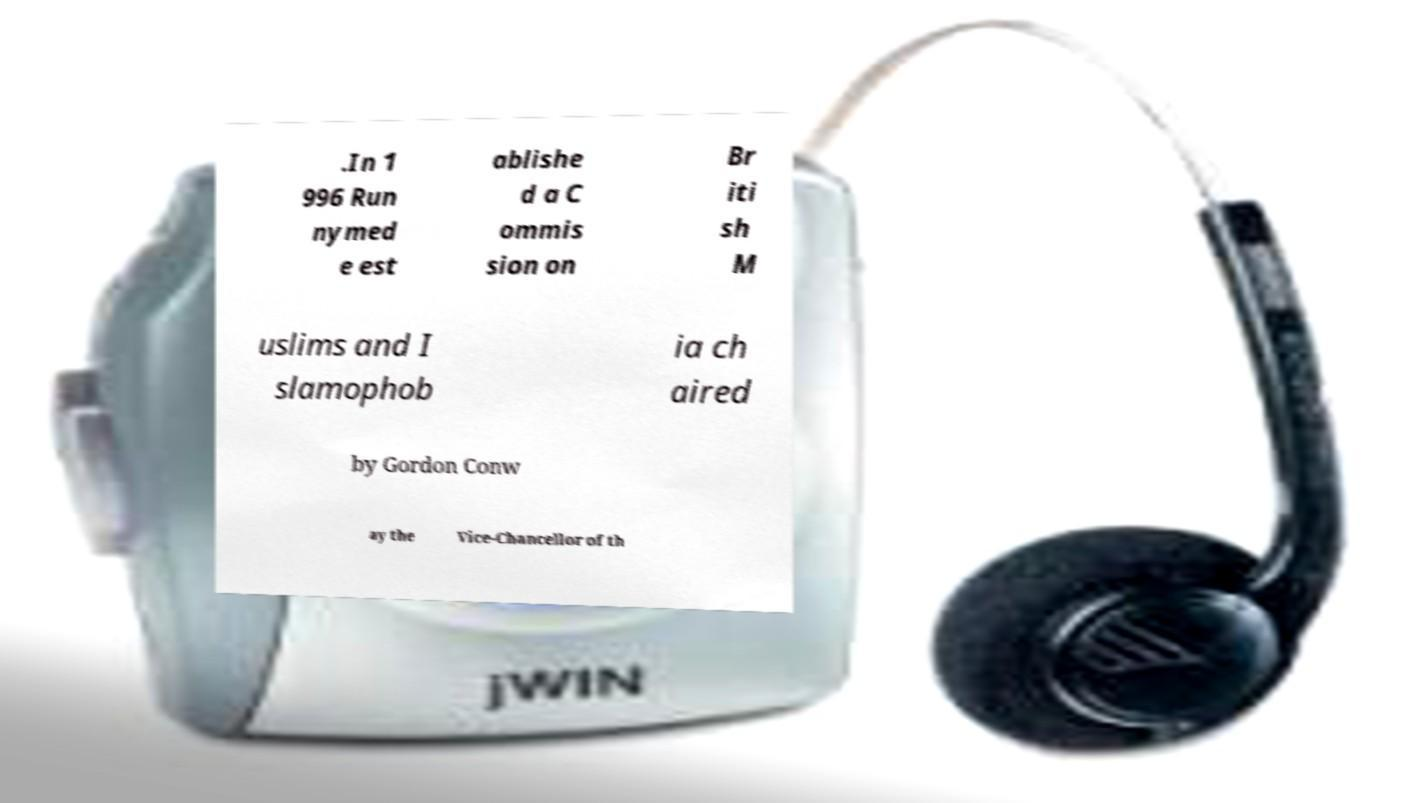There's text embedded in this image that I need extracted. Can you transcribe it verbatim? .In 1 996 Run nymed e est ablishe d a C ommis sion on Br iti sh M uslims and I slamophob ia ch aired by Gordon Conw ay the Vice-Chancellor of th 